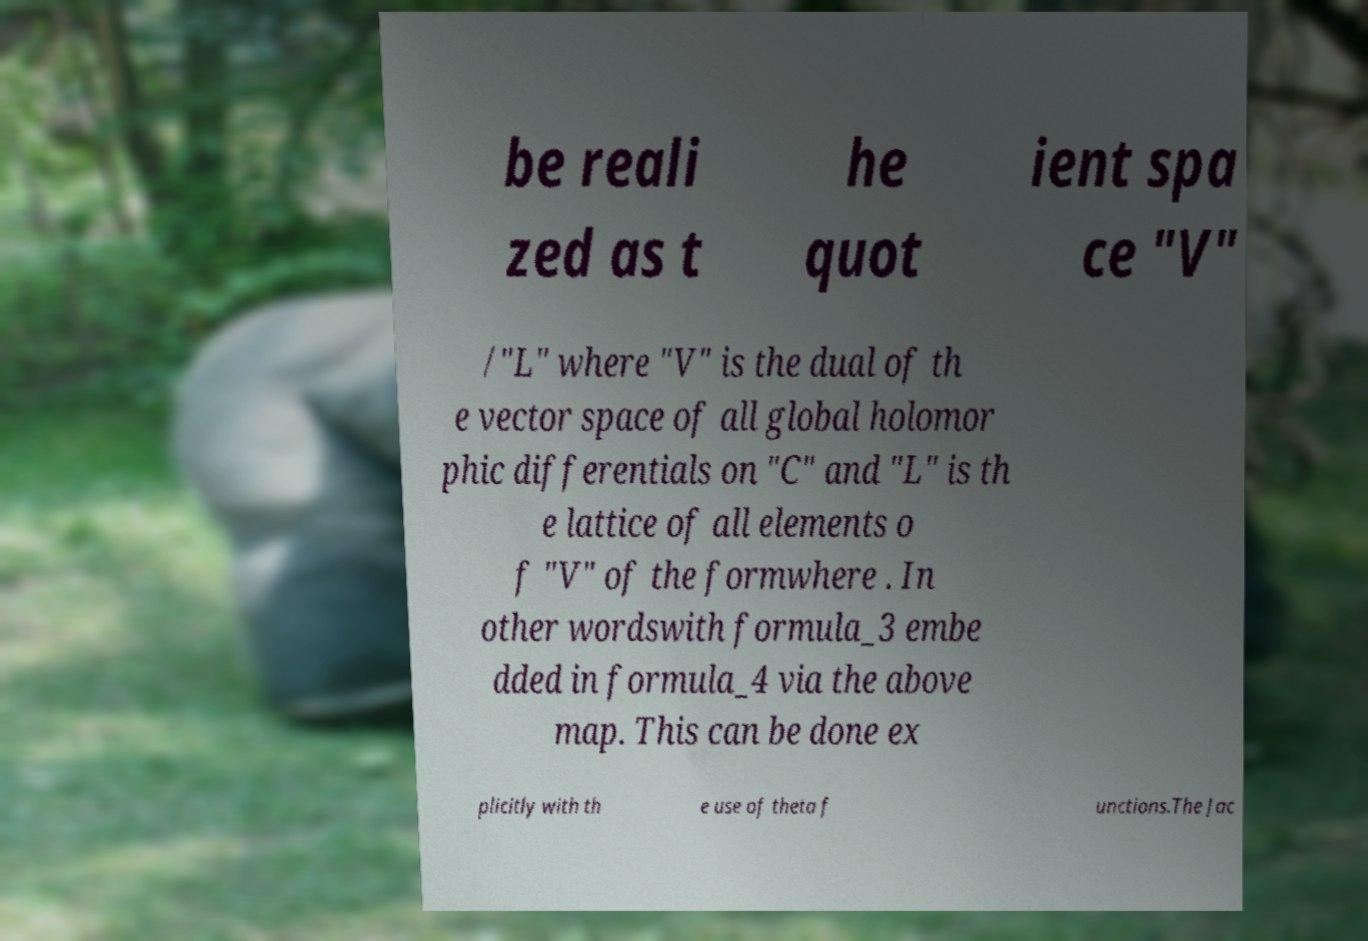Can you read and provide the text displayed in the image?This photo seems to have some interesting text. Can you extract and type it out for me? be reali zed as t he quot ient spa ce "V" /"L" where "V" is the dual of th e vector space of all global holomor phic differentials on "C" and "L" is th e lattice of all elements o f "V" of the formwhere . In other wordswith formula_3 embe dded in formula_4 via the above map. This can be done ex plicitly with th e use of theta f unctions.The Jac 